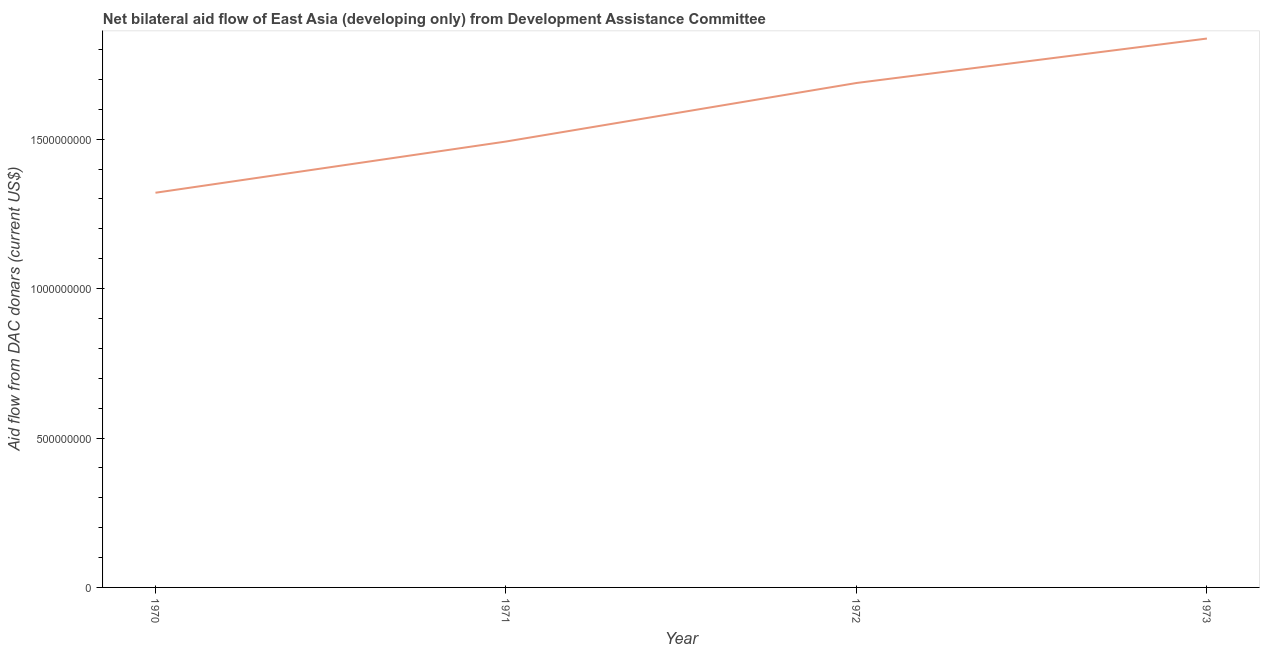What is the net bilateral aid flows from dac donors in 1973?
Provide a short and direct response. 1.84e+09. Across all years, what is the maximum net bilateral aid flows from dac donors?
Offer a terse response. 1.84e+09. Across all years, what is the minimum net bilateral aid flows from dac donors?
Make the answer very short. 1.32e+09. In which year was the net bilateral aid flows from dac donors minimum?
Offer a terse response. 1970. What is the sum of the net bilateral aid flows from dac donors?
Your answer should be very brief. 6.34e+09. What is the difference between the net bilateral aid flows from dac donors in 1970 and 1973?
Provide a short and direct response. -5.16e+08. What is the average net bilateral aid flows from dac donors per year?
Ensure brevity in your answer.  1.58e+09. What is the median net bilateral aid flows from dac donors?
Provide a short and direct response. 1.59e+09. Do a majority of the years between 1971 and 1972 (inclusive) have net bilateral aid flows from dac donors greater than 300000000 US$?
Your answer should be compact. Yes. What is the ratio of the net bilateral aid flows from dac donors in 1971 to that in 1972?
Offer a terse response. 0.88. What is the difference between the highest and the second highest net bilateral aid flows from dac donors?
Offer a very short reply. 1.49e+08. Is the sum of the net bilateral aid flows from dac donors in 1970 and 1973 greater than the maximum net bilateral aid flows from dac donors across all years?
Provide a succinct answer. Yes. What is the difference between the highest and the lowest net bilateral aid flows from dac donors?
Your response must be concise. 5.16e+08. Does the graph contain grids?
Keep it short and to the point. No. What is the title of the graph?
Make the answer very short. Net bilateral aid flow of East Asia (developing only) from Development Assistance Committee. What is the label or title of the Y-axis?
Your response must be concise. Aid flow from DAC donars (current US$). What is the Aid flow from DAC donars (current US$) of 1970?
Ensure brevity in your answer.  1.32e+09. What is the Aid flow from DAC donars (current US$) in 1971?
Offer a very short reply. 1.49e+09. What is the Aid flow from DAC donars (current US$) of 1972?
Offer a terse response. 1.69e+09. What is the Aid flow from DAC donars (current US$) of 1973?
Your response must be concise. 1.84e+09. What is the difference between the Aid flow from DAC donars (current US$) in 1970 and 1971?
Provide a succinct answer. -1.71e+08. What is the difference between the Aid flow from DAC donars (current US$) in 1970 and 1972?
Provide a short and direct response. -3.67e+08. What is the difference between the Aid flow from DAC donars (current US$) in 1970 and 1973?
Offer a terse response. -5.16e+08. What is the difference between the Aid flow from DAC donars (current US$) in 1971 and 1972?
Your answer should be compact. -1.96e+08. What is the difference between the Aid flow from DAC donars (current US$) in 1971 and 1973?
Your response must be concise. -3.45e+08. What is the difference between the Aid flow from DAC donars (current US$) in 1972 and 1973?
Make the answer very short. -1.49e+08. What is the ratio of the Aid flow from DAC donars (current US$) in 1970 to that in 1971?
Your answer should be compact. 0.89. What is the ratio of the Aid flow from DAC donars (current US$) in 1970 to that in 1972?
Your answer should be very brief. 0.78. What is the ratio of the Aid flow from DAC donars (current US$) in 1970 to that in 1973?
Give a very brief answer. 0.72. What is the ratio of the Aid flow from DAC donars (current US$) in 1971 to that in 1972?
Provide a short and direct response. 0.88. What is the ratio of the Aid flow from DAC donars (current US$) in 1971 to that in 1973?
Offer a terse response. 0.81. What is the ratio of the Aid flow from DAC donars (current US$) in 1972 to that in 1973?
Offer a terse response. 0.92. 